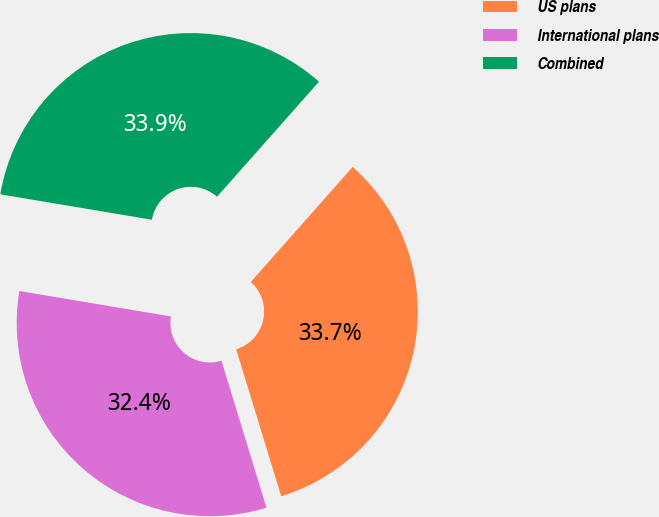<chart> <loc_0><loc_0><loc_500><loc_500><pie_chart><fcel>US plans<fcel>International plans<fcel>Combined<nl><fcel>33.73%<fcel>32.38%<fcel>33.89%<nl></chart> 